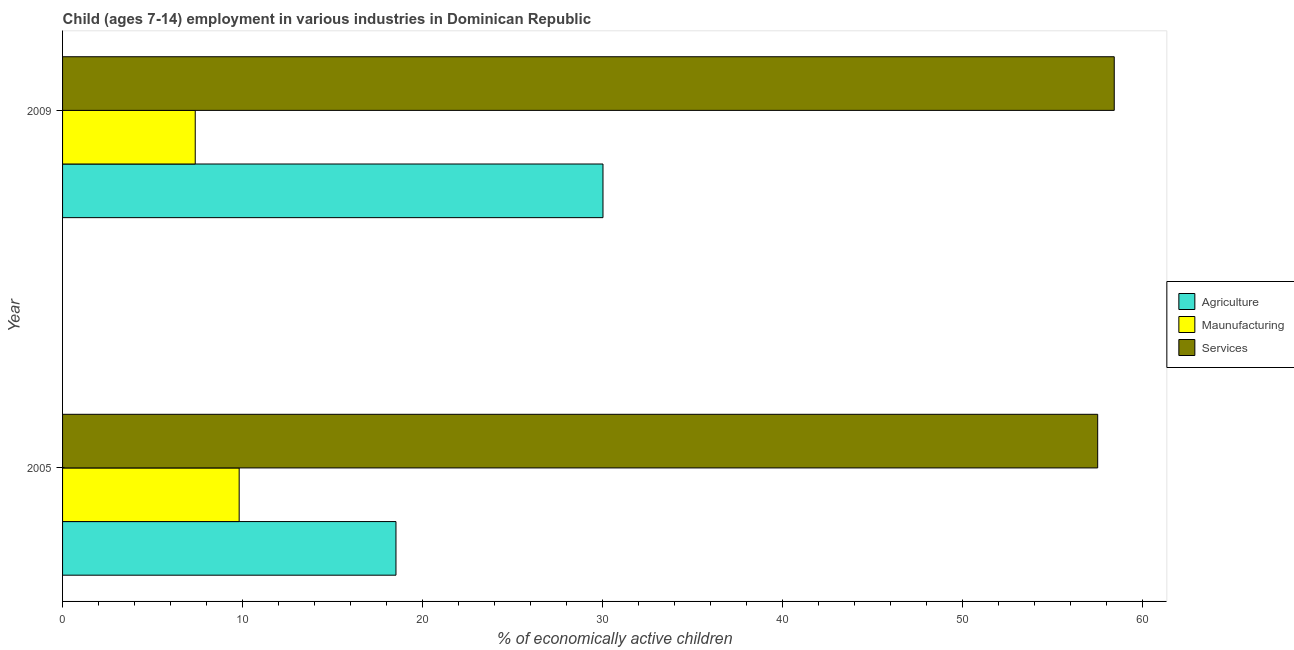How many groups of bars are there?
Provide a short and direct response. 2. Are the number of bars per tick equal to the number of legend labels?
Keep it short and to the point. Yes. How many bars are there on the 1st tick from the top?
Your response must be concise. 3. What is the label of the 1st group of bars from the top?
Provide a succinct answer. 2009. In how many cases, is the number of bars for a given year not equal to the number of legend labels?
Offer a terse response. 0. What is the percentage of economically active children in agriculture in 2009?
Make the answer very short. 30.02. Across all years, what is the maximum percentage of economically active children in agriculture?
Provide a short and direct response. 30.02. Across all years, what is the minimum percentage of economically active children in services?
Offer a terse response. 57.5. In which year was the percentage of economically active children in agriculture maximum?
Your response must be concise. 2009. In which year was the percentage of economically active children in agriculture minimum?
Make the answer very short. 2005. What is the total percentage of economically active children in manufacturing in the graph?
Provide a short and direct response. 17.18. What is the difference between the percentage of economically active children in manufacturing in 2005 and that in 2009?
Your response must be concise. 2.44. What is the difference between the percentage of economically active children in manufacturing in 2009 and the percentage of economically active children in agriculture in 2005?
Offer a very short reply. -11.15. What is the average percentage of economically active children in services per year?
Provide a short and direct response. 57.96. In the year 2009, what is the difference between the percentage of economically active children in agriculture and percentage of economically active children in services?
Offer a terse response. -28.4. In how many years, is the percentage of economically active children in services greater than 30 %?
Offer a terse response. 2. What is the ratio of the percentage of economically active children in manufacturing in 2005 to that in 2009?
Your answer should be very brief. 1.33. What does the 3rd bar from the top in 2009 represents?
Ensure brevity in your answer.  Agriculture. What does the 2nd bar from the bottom in 2005 represents?
Your answer should be compact. Maunufacturing. How many bars are there?
Keep it short and to the point. 6. Are the values on the major ticks of X-axis written in scientific E-notation?
Ensure brevity in your answer.  No. How are the legend labels stacked?
Provide a short and direct response. Vertical. What is the title of the graph?
Your answer should be very brief. Child (ages 7-14) employment in various industries in Dominican Republic. Does "Secondary education" appear as one of the legend labels in the graph?
Ensure brevity in your answer.  No. What is the label or title of the X-axis?
Offer a terse response. % of economically active children. What is the % of economically active children of Agriculture in 2005?
Offer a very short reply. 18.52. What is the % of economically active children in Maunufacturing in 2005?
Offer a terse response. 9.81. What is the % of economically active children of Services in 2005?
Your response must be concise. 57.5. What is the % of economically active children of Agriculture in 2009?
Your answer should be compact. 30.02. What is the % of economically active children of Maunufacturing in 2009?
Provide a short and direct response. 7.37. What is the % of economically active children in Services in 2009?
Your response must be concise. 58.42. Across all years, what is the maximum % of economically active children in Agriculture?
Provide a short and direct response. 30.02. Across all years, what is the maximum % of economically active children of Maunufacturing?
Your response must be concise. 9.81. Across all years, what is the maximum % of economically active children in Services?
Your answer should be very brief. 58.42. Across all years, what is the minimum % of economically active children of Agriculture?
Give a very brief answer. 18.52. Across all years, what is the minimum % of economically active children in Maunufacturing?
Keep it short and to the point. 7.37. Across all years, what is the minimum % of economically active children of Services?
Offer a terse response. 57.5. What is the total % of economically active children in Agriculture in the graph?
Your answer should be compact. 48.54. What is the total % of economically active children of Maunufacturing in the graph?
Your answer should be very brief. 17.18. What is the total % of economically active children of Services in the graph?
Provide a succinct answer. 115.92. What is the difference between the % of economically active children of Maunufacturing in 2005 and that in 2009?
Your response must be concise. 2.44. What is the difference between the % of economically active children of Services in 2005 and that in 2009?
Your answer should be compact. -0.92. What is the difference between the % of economically active children in Agriculture in 2005 and the % of economically active children in Maunufacturing in 2009?
Provide a succinct answer. 11.15. What is the difference between the % of economically active children of Agriculture in 2005 and the % of economically active children of Services in 2009?
Your response must be concise. -39.9. What is the difference between the % of economically active children of Maunufacturing in 2005 and the % of economically active children of Services in 2009?
Ensure brevity in your answer.  -48.61. What is the average % of economically active children of Agriculture per year?
Your answer should be very brief. 24.27. What is the average % of economically active children in Maunufacturing per year?
Ensure brevity in your answer.  8.59. What is the average % of economically active children of Services per year?
Make the answer very short. 57.96. In the year 2005, what is the difference between the % of economically active children in Agriculture and % of economically active children in Maunufacturing?
Make the answer very short. 8.71. In the year 2005, what is the difference between the % of economically active children in Agriculture and % of economically active children in Services?
Provide a succinct answer. -38.98. In the year 2005, what is the difference between the % of economically active children in Maunufacturing and % of economically active children in Services?
Provide a succinct answer. -47.69. In the year 2009, what is the difference between the % of economically active children in Agriculture and % of economically active children in Maunufacturing?
Your answer should be very brief. 22.65. In the year 2009, what is the difference between the % of economically active children in Agriculture and % of economically active children in Services?
Provide a short and direct response. -28.4. In the year 2009, what is the difference between the % of economically active children in Maunufacturing and % of economically active children in Services?
Give a very brief answer. -51.05. What is the ratio of the % of economically active children of Agriculture in 2005 to that in 2009?
Offer a very short reply. 0.62. What is the ratio of the % of economically active children of Maunufacturing in 2005 to that in 2009?
Ensure brevity in your answer.  1.33. What is the ratio of the % of economically active children in Services in 2005 to that in 2009?
Make the answer very short. 0.98. What is the difference between the highest and the second highest % of economically active children of Agriculture?
Offer a terse response. 11.5. What is the difference between the highest and the second highest % of economically active children of Maunufacturing?
Ensure brevity in your answer.  2.44. What is the difference between the highest and the second highest % of economically active children of Services?
Your answer should be compact. 0.92. What is the difference between the highest and the lowest % of economically active children in Maunufacturing?
Keep it short and to the point. 2.44. What is the difference between the highest and the lowest % of economically active children of Services?
Give a very brief answer. 0.92. 